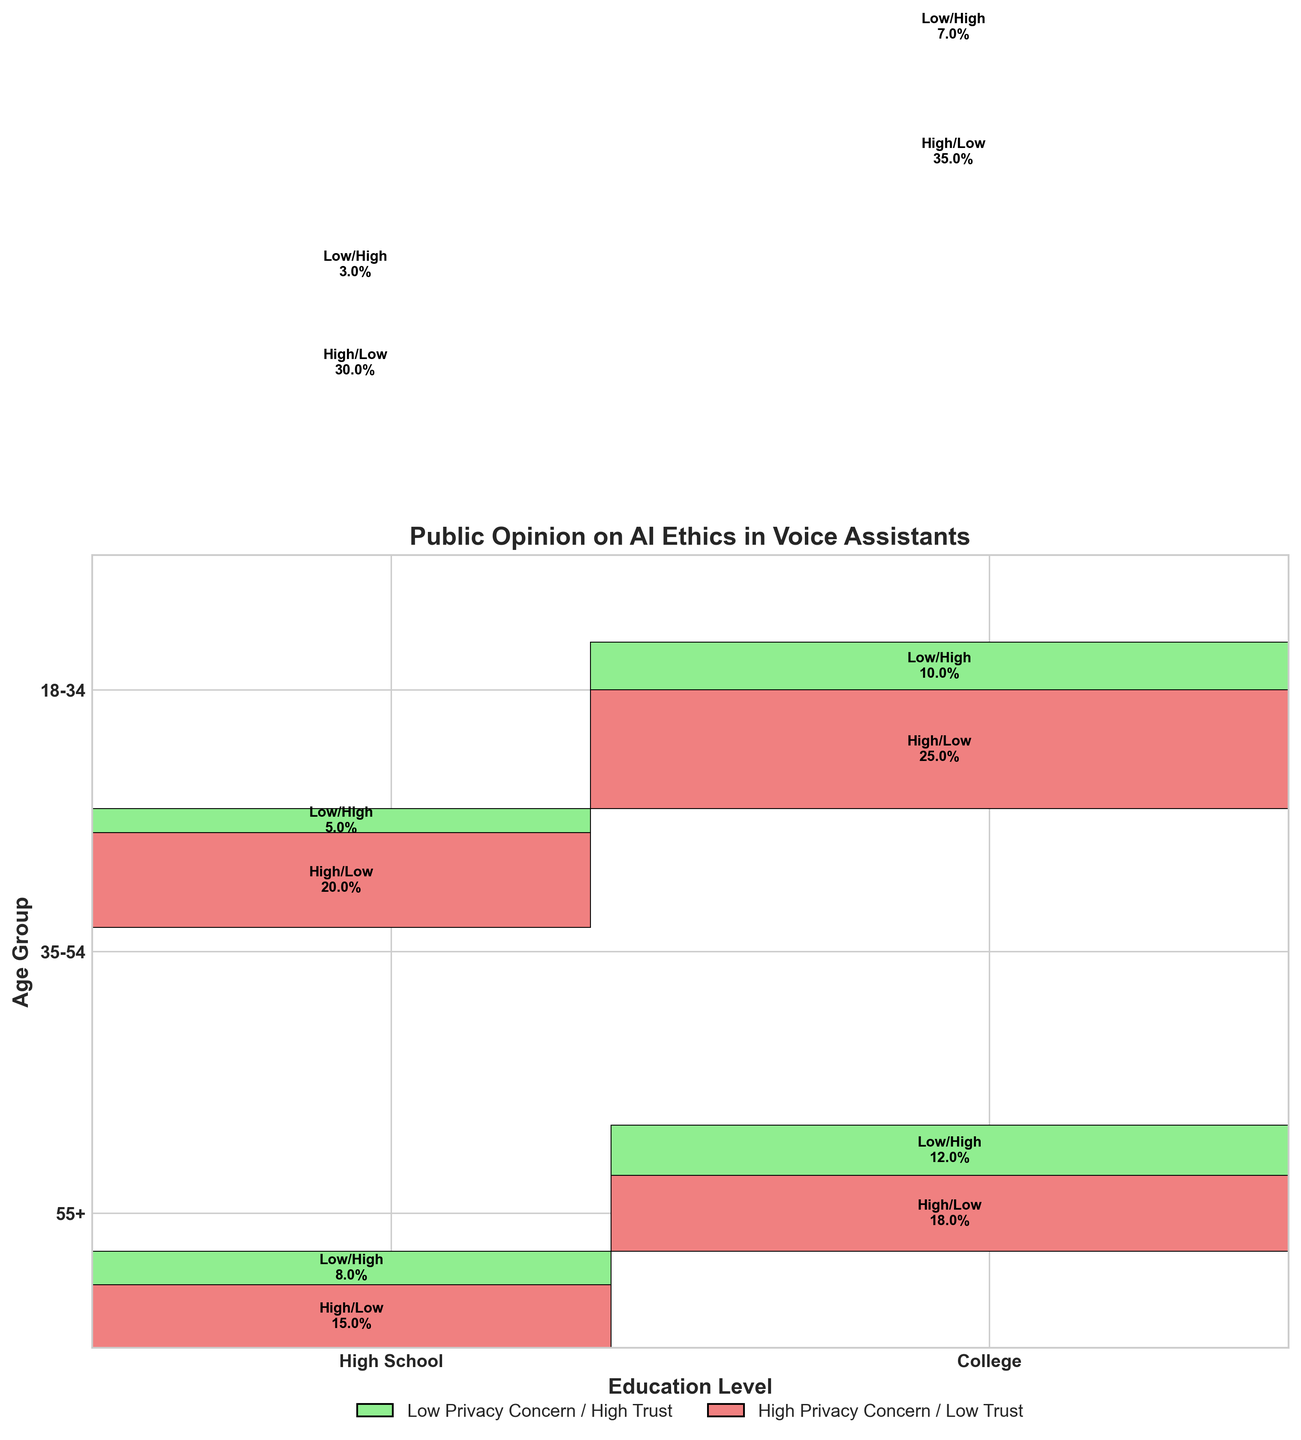What is the title of the figure? The title is usually found at the top of the figure. In this case, the title reads "Public Opinion on AI Ethics in Voice Assistants."
Answer: Public Opinion on AI Ethics in Voice Assistants Which age group has the highest percentage of low privacy concern and high trust? To find this, look for the light green rectangles indicating low privacy concern and high trust across different age groups and compare the percentages. The age group 18-34 has 8% and 12%, the age group 35-54 has 5% and 10%, and the age group 55+ has 3% and 7%. Therefore, the age group 18-34 has the highest percentage.
Answer: 18-34 What is the sum of percentages for high privacy concern and low trust in the 55+ age group? For the 55+ age group, locate the light coral rectangles. The percentages are 30% for high school education and 35% for college education. Summing these gives 30% + 35%.
Answer: 65% Which educational level in the 35-54 age group has more respondents with high privacy concern and low trust? For the 35-54 age group, look at the light coral rectangles. The high school level has 20%, and the college level has 25%. Since 25% is greater than 20%, the college level has more respondents with high privacy concern and low trust.
Answer: College Do more respondents in the 18-34 age group with college education have high privacy concerns and low trust compared to those with high school education? In the 18-34 age group, find the respondents with college education under high privacy concern and low trust (18%) and compare it to high school education under the same category (15%). 18% is greater than 15%.
Answer: Yes Does the figure indicate which age group has the least concern with privacy and highest trust? Look for the light green rectangles indicating low privacy concern and high trust across age groups. The 55+ group has the smallest percentages (3% and 7%), which are smaller compared to other age groups.
Answer: Yes Which age group overall has the highest percentage of respondents with high privacy concerns and low trust? Sum the percentages of high privacy concern and low trust for each age group. For 18-34: 15% + 18% = 33%, for 35-54: 20% + 25% = 45%, and for 55+: 30% + 35% = 65%. The 55+ age group has the highest percentage.
Answer: 55+ What is the total percentage of "College educated" respondents across all age groups with low privacy concern and high trust? Locate all college-educated, low privacy concern, and high trust (light green) percentages and sum them up: 18-34 (12%), 35-54 (10%), 55+ (7%). Sum: 12% + 10% + 7%.
Answer: 29% In the figure, which group has the smallest percentage of respondents with low privacy concern and high trust? Look for the smallest light green rectangles. The 55+ age group with high school education has the smallest percentage with 3%.
Answer: 55+ with High School Is there a significant difference between the concerns of the 35-54 and 55+ age groups regarding high privacy concern and low trust? Compare the light coral percentages of the 35-54 age group (20% high school and 25% college) to the 55+ age group (30% high school and 35% college). The difference is noticeable: 55+ has significantly higher percentages.
Answer: Yes 